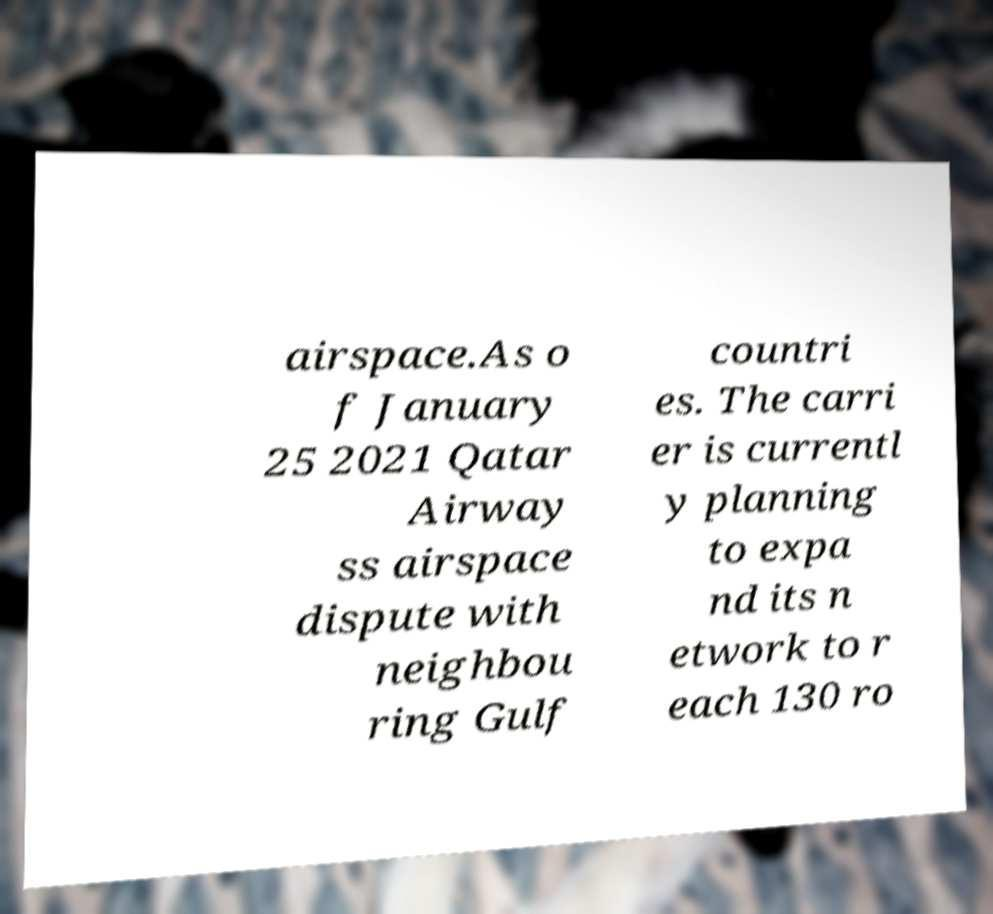There's text embedded in this image that I need extracted. Can you transcribe it verbatim? airspace.As o f January 25 2021 Qatar Airway ss airspace dispute with neighbou ring Gulf countri es. The carri er is currentl y planning to expa nd its n etwork to r each 130 ro 